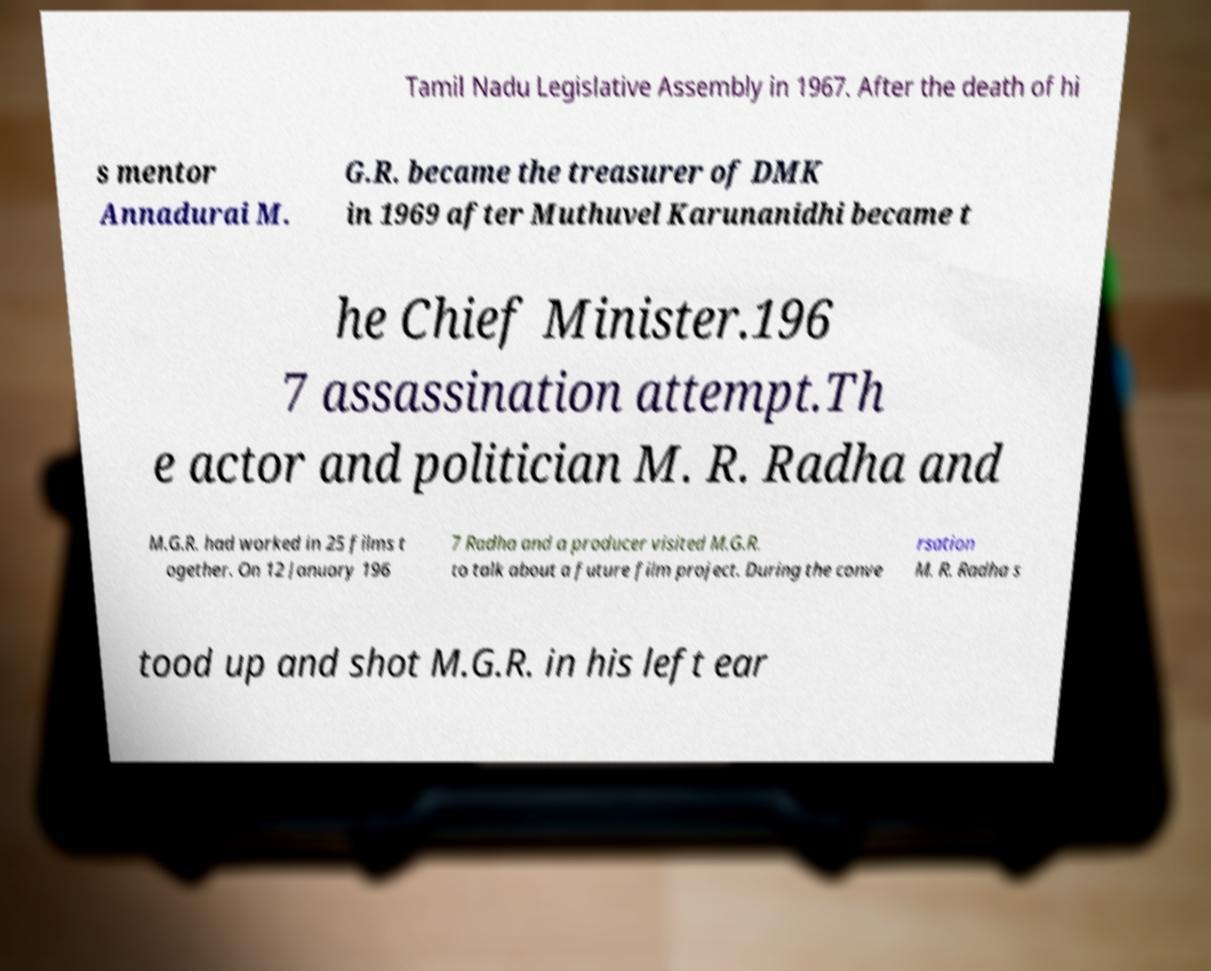What messages or text are displayed in this image? I need them in a readable, typed format. Tamil Nadu Legislative Assembly in 1967. After the death of hi s mentor Annadurai M. G.R. became the treasurer of DMK in 1969 after Muthuvel Karunanidhi became t he Chief Minister.196 7 assassination attempt.Th e actor and politician M. R. Radha and M.G.R. had worked in 25 films t ogether. On 12 January 196 7 Radha and a producer visited M.G.R. to talk about a future film project. During the conve rsation M. R. Radha s tood up and shot M.G.R. in his left ear 